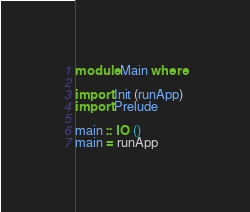Convert code to text. <code><loc_0><loc_0><loc_500><loc_500><_Haskell_>module Main where

import Init (runApp)
import Prelude

main :: IO ()
main = runApp
</code> 